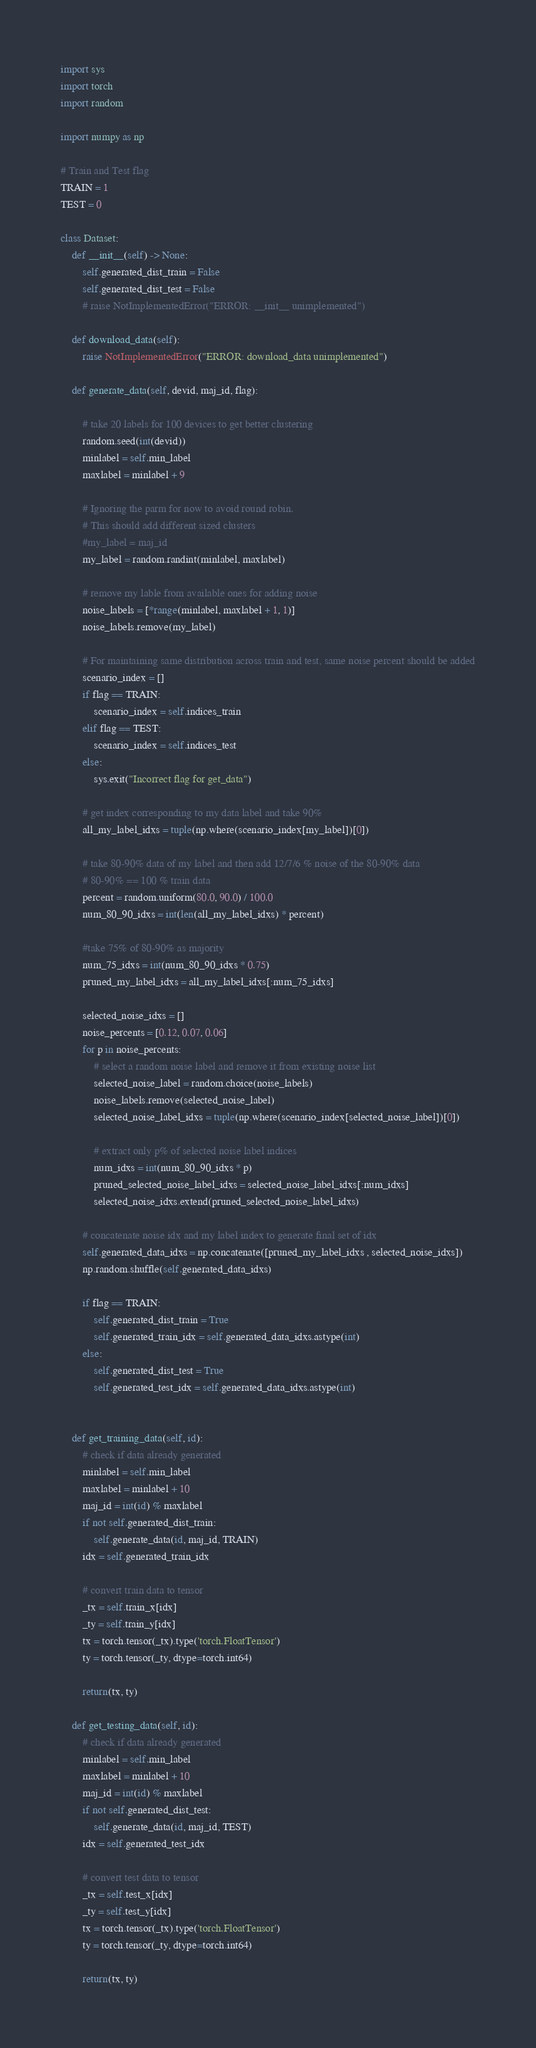Convert code to text. <code><loc_0><loc_0><loc_500><loc_500><_Python_>import sys
import torch
import random

import numpy as np

# Train and Test flag
TRAIN = 1
TEST = 0

class Dataset:
    def __init__(self) -> None:
        self.generated_dist_train = False
        self.generated_dist_test = False
        # raise NotImplementedError("ERROR: __init__ unimplemented")

    def download_data(self):
        raise NotImplementedError("ERROR: download_data unimplemented")
    
    def generate_data(self, devid, maj_id, flag):

        # take 20 labels for 100 devices to get better clustering
        random.seed(int(devid))
        minlabel = self.min_label
        maxlabel = minlabel + 9

        # Ignoring the parm for now to avoid round robin.
        # This should add different sized clusters
        #my_label = maj_id
        my_label = random.randint(minlabel, maxlabel)

        # remove my lable from available ones for adding noise
        noise_labels = [*range(minlabel, maxlabel + 1, 1)]
        noise_labels.remove(my_label)

        # For maintaining same distribution across train and test, same noise percent should be added
        scenario_index = []
        if flag == TRAIN:
            scenario_index = self.indices_train
        elif flag == TEST:
            scenario_index = self.indices_test
        else:
            sys.exit("Incorrect flag for get_data")

        # get index corresponding to my data label and take 90%
        all_my_label_idxs = tuple(np.where(scenario_index[my_label])[0])

        # take 80-90% data of my label and then add 12/7/6 % noise of the 80-90% data
        # 80-90% == 100 % train data
        percent = random.uniform(80.0, 90.0) / 100.0
        num_80_90_idxs = int(len(all_my_label_idxs) * percent)

        #take 75% of 80-90% as majority
        num_75_idxs = int(num_80_90_idxs * 0.75)
        pruned_my_label_idxs = all_my_label_idxs[:num_75_idxs]

        selected_noise_idxs = []
        noise_percents = [0.12, 0.07, 0.06]
        for p in noise_percents:
            # select a random noise label and remove it from existing noise list 
            selected_noise_label = random.choice(noise_labels)
            noise_labels.remove(selected_noise_label)
            selected_noise_label_idxs = tuple(np.where(scenario_index[selected_noise_label])[0])

            # extract only p% of selected noise label indices
            num_idxs = int(num_80_90_idxs * p)
            pruned_selected_noise_label_idxs = selected_noise_label_idxs[:num_idxs]
            selected_noise_idxs.extend(pruned_selected_noise_label_idxs)

        # concatenate noise idx and my label index to generate final set of idx
        self.generated_data_idxs = np.concatenate([pruned_my_label_idxs , selected_noise_idxs])
        np.random.shuffle(self.generated_data_idxs)

        if flag == TRAIN:
            self.generated_dist_train = True
            self.generated_train_idx = self.generated_data_idxs.astype(int)
        else:
            self.generated_dist_test = True
            self.generated_test_idx = self.generated_data_idxs.astype(int)
        

    def get_training_data(self, id):
        # check if data already generated
        minlabel = self.min_label
        maxlabel = minlabel + 10
        maj_id = int(id) % maxlabel
        if not self.generated_dist_train:
            self.generate_data(id, maj_id, TRAIN)
        idx = self.generated_train_idx

        # convert train data to tensor
        _tx = self.train_x[idx]
        _ty = self.train_y[idx]
        tx = torch.tensor(_tx).type('torch.FloatTensor')
        ty = torch.tensor(_ty, dtype=torch.int64)

        return(tx, ty)

    def get_testing_data(self, id):
        # check if data already generated
        minlabel = self.min_label
        maxlabel = minlabel + 10
        maj_id = int(id) % maxlabel
        if not self.generated_dist_test:
            self.generate_data(id, maj_id, TEST)
        idx = self.generated_test_idx
    
        # convert test data to tensor
        _tx = self.test_x[idx]
        _ty = self.test_y[idx]
        tx = torch.tensor(_tx).type('torch.FloatTensor')
        ty = torch.tensor(_ty, dtype=torch.int64)
        
        return(tx, ty)
</code> 